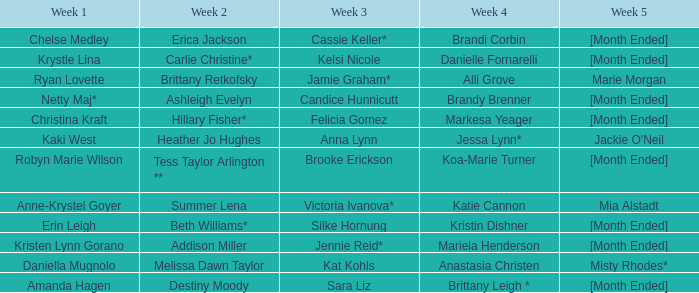What is the week 1 with candice hunnicutt in week 3? Netty Maj*. 